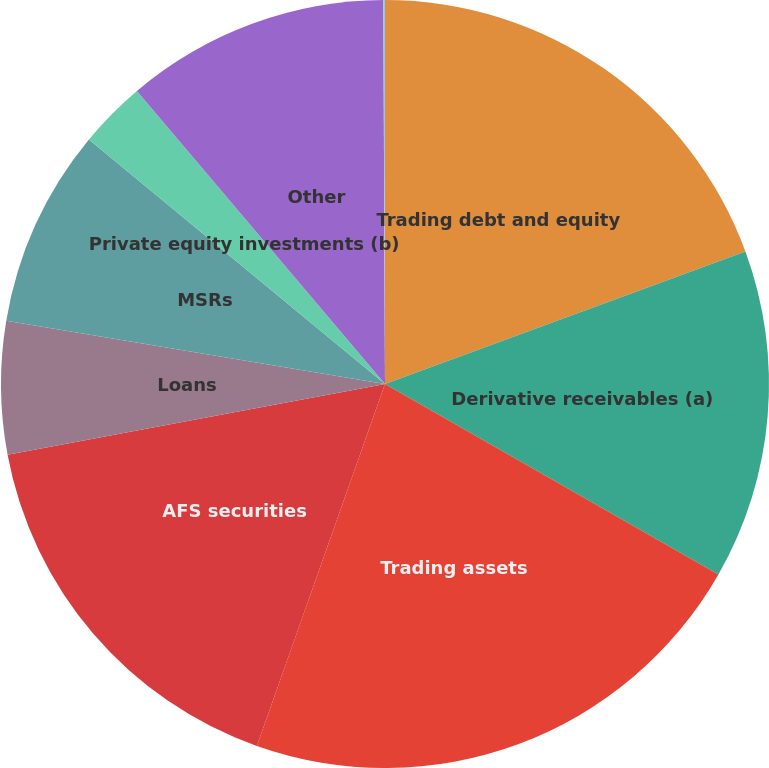<chart> <loc_0><loc_0><loc_500><loc_500><pie_chart><fcel>Trading debt and equity<fcel>Derivative receivables (a)<fcel>Trading assets<fcel>AFS securities<fcel>Loans<fcel>MSRs<fcel>Private equity investments (b)<fcel>Other<fcel>Total assets measured at fair<nl><fcel>19.39%<fcel>13.87%<fcel>22.15%<fcel>16.63%<fcel>5.59%<fcel>8.35%<fcel>2.83%<fcel>11.11%<fcel>0.07%<nl></chart> 